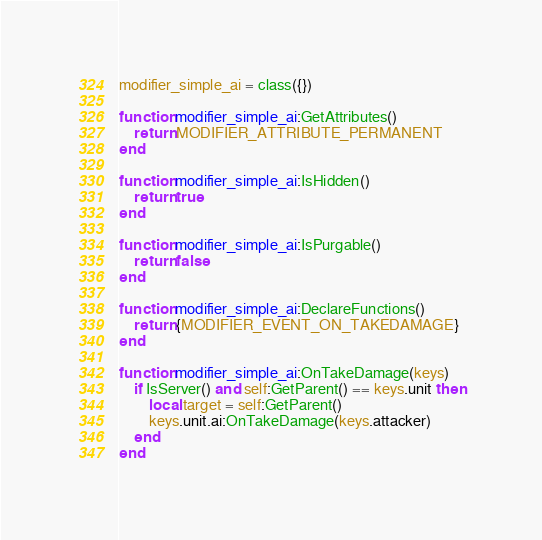Convert code to text. <code><loc_0><loc_0><loc_500><loc_500><_Lua_>modifier_simple_ai = class({})

function modifier_simple_ai:GetAttributes()
	return MODIFIER_ATTRIBUTE_PERMANENT
end

function modifier_simple_ai:IsHidden()
	return true
end

function modifier_simple_ai:IsPurgable()
	return false
end

function modifier_simple_ai:DeclareFunctions()
	return {MODIFIER_EVENT_ON_TAKEDAMAGE}
end

function modifier_simple_ai:OnTakeDamage(keys)
	if IsServer() and self:GetParent() == keys.unit then
		local target = self:GetParent()
		keys.unit.ai:OnTakeDamage(keys.attacker)
	end
end</code> 